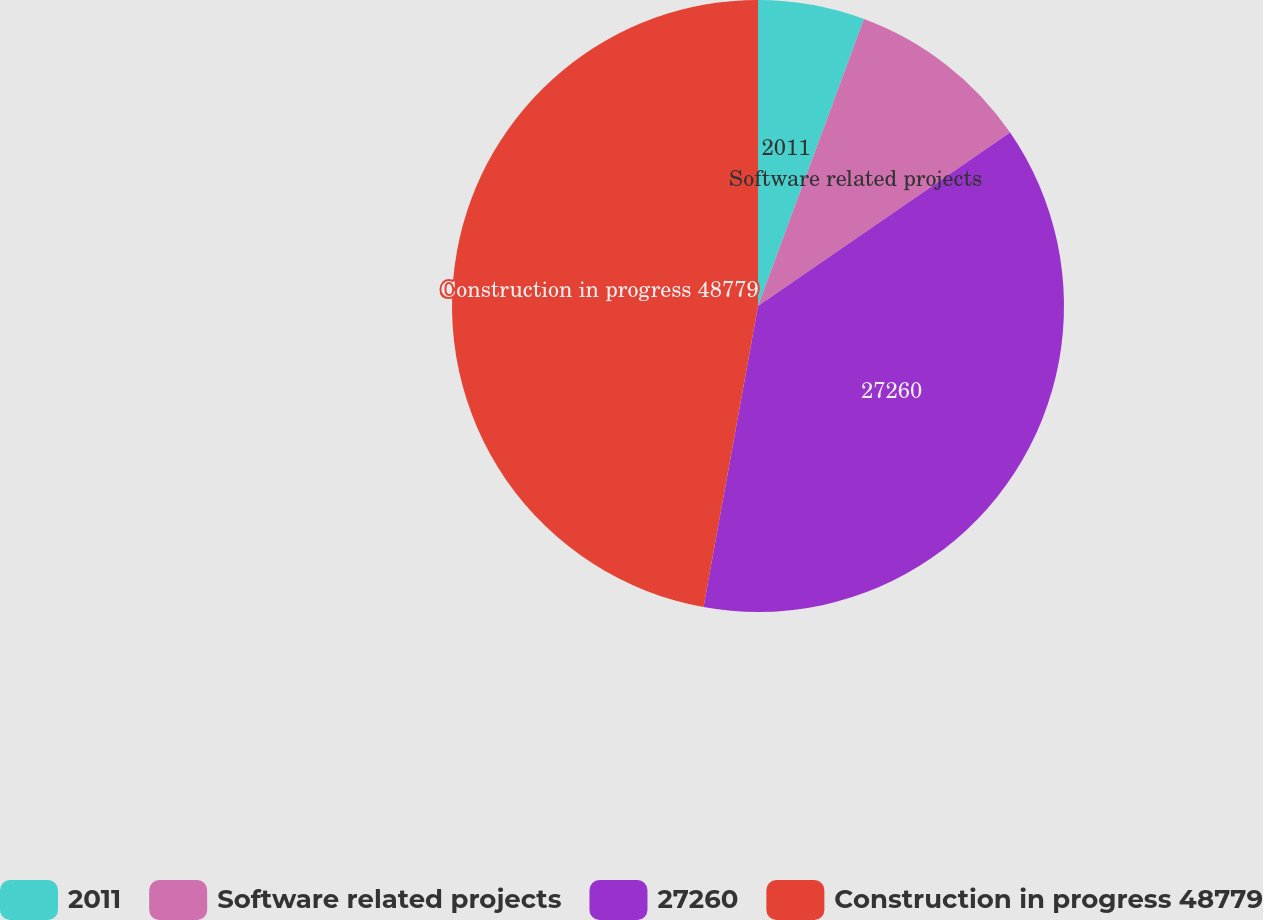Convert chart. <chart><loc_0><loc_0><loc_500><loc_500><pie_chart><fcel>2011<fcel>Software related projects<fcel>27260<fcel>Construction in progress 48779<nl><fcel>5.63%<fcel>9.78%<fcel>37.44%<fcel>47.15%<nl></chart> 